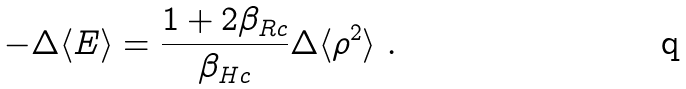<formula> <loc_0><loc_0><loc_500><loc_500>- \Delta \langle E \rangle = \frac { 1 + 2 \beta _ { R c } } { \beta _ { H c } } \Delta \langle \rho ^ { 2 } \rangle \ .</formula> 